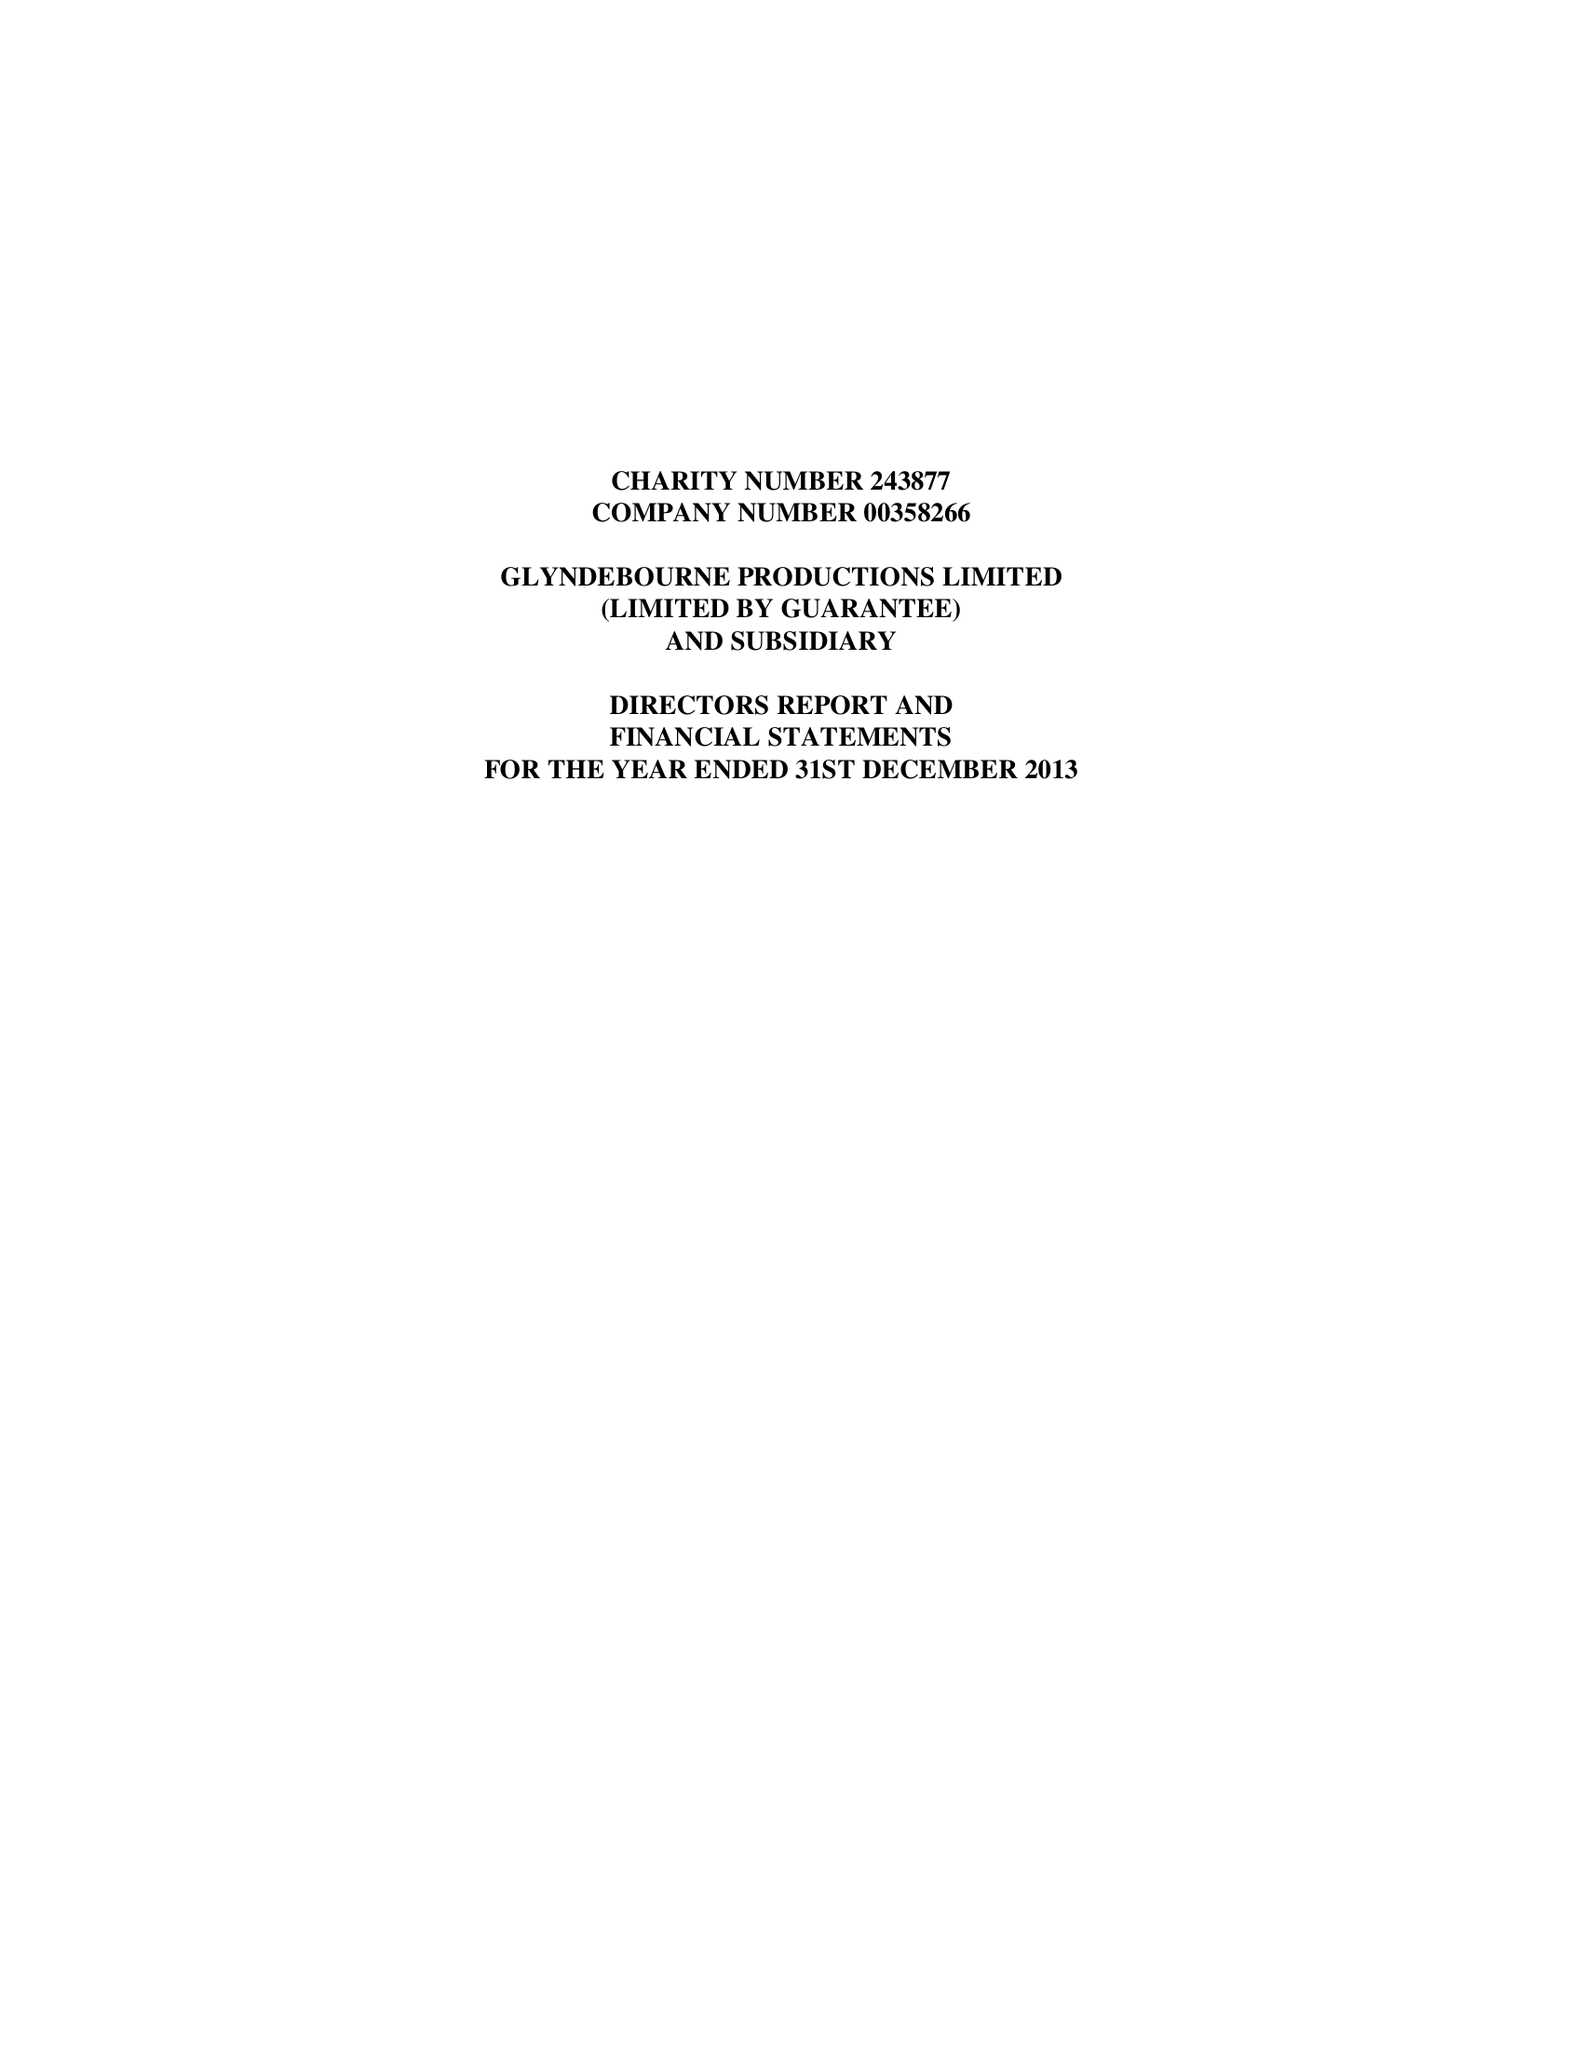What is the value for the charity_number?
Answer the question using a single word or phrase. 243877 